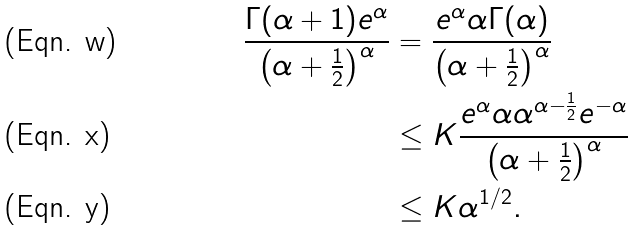Convert formula to latex. <formula><loc_0><loc_0><loc_500><loc_500>\frac { \Gamma ( \alpha + 1 ) e ^ { \alpha } } { \left ( \alpha + \frac { 1 } { 2 } \right ) ^ { \alpha } } & = \frac { e ^ { \alpha } \alpha \Gamma ( \alpha ) } { \left ( \alpha + \frac { 1 } { 2 } \right ) ^ { \alpha } } \\ & \leq K \frac { e ^ { \alpha } \alpha \alpha ^ { \alpha - \frac { 1 } { 2 } } e ^ { - \alpha } } { \left ( \alpha + \frac { 1 } { 2 } \right ) ^ { \alpha } } \\ & \leq K \alpha ^ { 1 / 2 } .</formula> 